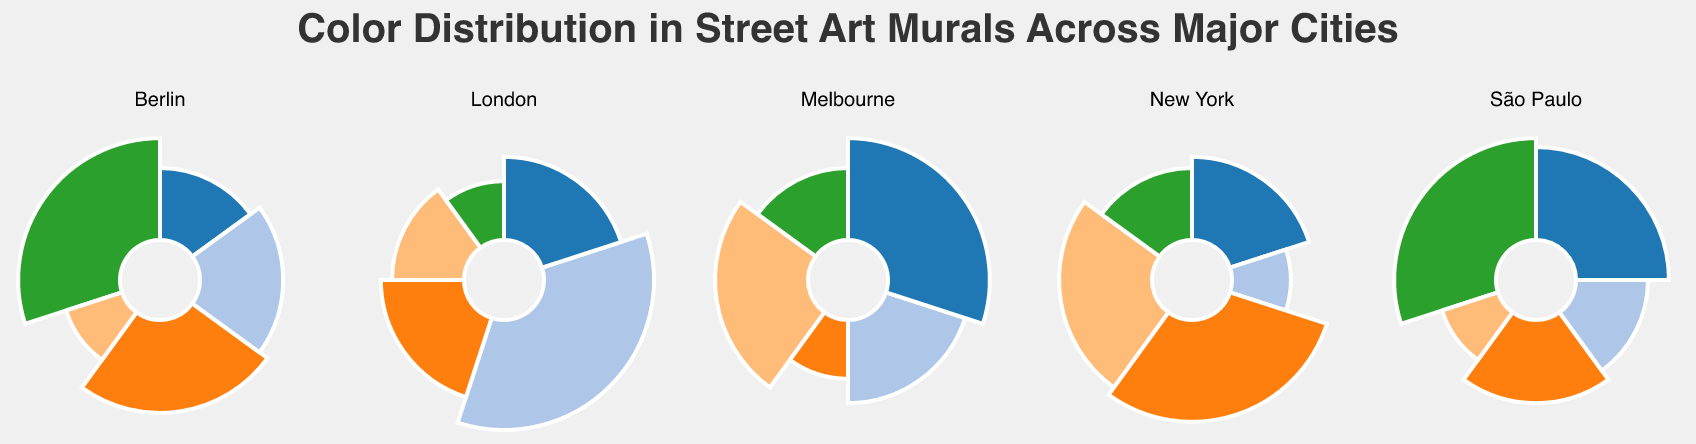What is the most prominent color in New York's street art murals? The Purple section in the New York subplot appears largest, indicating it has the highest percentage at 30%.
Answer: Purple How does the percentage of Red in New York compare to Crimson in Melbourne? In the New York subplot, Red has 25%, while the Melbourne subplot shows Crimson at 30%. Comparing these, Crimson in Melbourne is higher by 5%.
Answer: Crimson in Melbourne is higher Which city uses more Teal in their street art murals, London or Berlin? London is the only city that has Teal at 15% in its Polar Chart, whereas Berlin doesn't have Teal listed at all.
Answer: London What color is unique to São Paulo's street art murals compared to the other cities? The São Paulo subplot shows colors like Aqua, Fuchsia, Chartreuse, Violet, and Sienna. Comparing this to other subplots, Chartreuse is unique to São Paulo.
Answer: Chartreuse Which two cities use the color with a 25% share in their murals, and what are those colors? In New York, Red is 25%, and in Berlin, Magenta is 25%. Thus, Red for New York and Magenta for Berlin.
Answer: New York (Red) and Berlin (Magenta) What is the total percentage of the top three colors used in London's street art murals? London's top three colors are Orange (35%), Pink (20%), and Black (20%). Their total is 35% + 20% + 20% = 75%.
Answer: 75% How does the color distribution in Berlin compare to New York in terms of variety? Berlin has 5 colors (Turquoise, Magenta, Gold, Silver, Lime), and New York also has 5 colors (Red, Blue, Yellow, Green, Purple). Both cities have the same number of distinct colors.
Answer: Same variety Which city has equal percentages of any two colors in its street art murals? São Paulo has an equal percentage of 20% for both Aqua and Fuchsia.
Answer: São Paulo What is the difference in percentage between the most and least used colors in Melbourne's street art? The most used color in Melbourne is Crimson (30%) and the least used is Maroon (10%). The difference is 30% - 10% = 20%.
Answer: 20% Which color in London’s murals has a greater share than any of New York’s colors? London's Orange is at 35%, which is greater than the highest percentage in New York (Purple at 30%).
Answer: Orange 